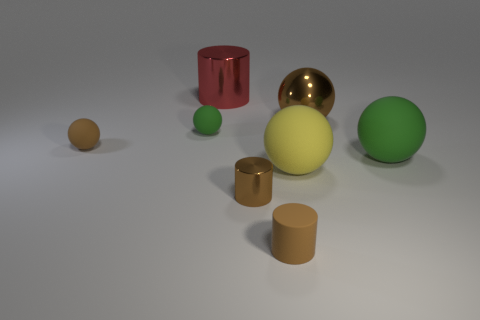Subtract all yellow spheres. How many spheres are left? 4 Subtract all small brown rubber spheres. How many spheres are left? 4 Subtract all yellow spheres. Subtract all red cubes. How many spheres are left? 4 Add 1 tiny red metal objects. How many objects exist? 9 Subtract all cylinders. How many objects are left? 5 Subtract 0 purple cylinders. How many objects are left? 8 Subtract all large red metal cylinders. Subtract all big brown objects. How many objects are left? 6 Add 2 brown metallic cylinders. How many brown metallic cylinders are left? 3 Add 4 matte spheres. How many matte spheres exist? 8 